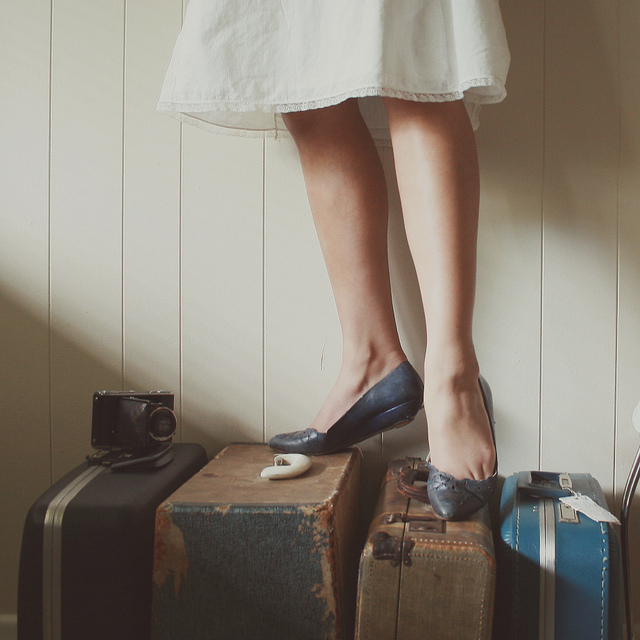Describe the atmosphere this image might be trying to convey. The image exudes a tranquil, yet anticipatory atmosphere. The understated color palette and soft lighting give it a calm and timeless quality. The person poised on the suitcases could be contemplating a forthcoming journey or reflecting on past travels. The inclusion of the classic camera adds an artistic touch, hinting that these travels may also be quests for capturing memories and beautiful moments. 